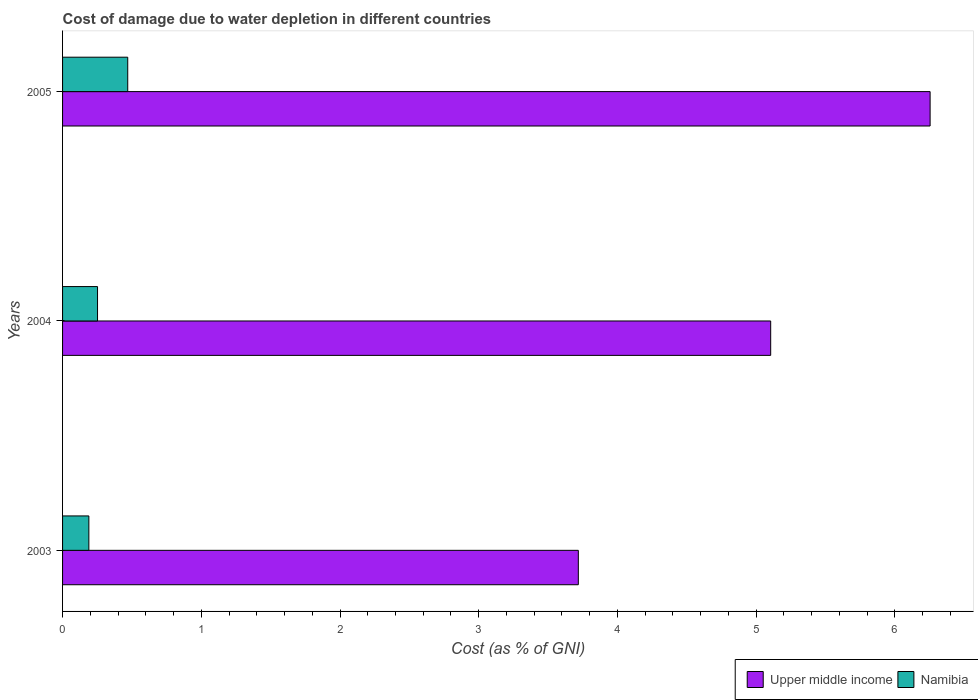How many groups of bars are there?
Offer a terse response. 3. What is the cost of damage caused due to water depletion in Upper middle income in 2003?
Your response must be concise. 3.72. Across all years, what is the maximum cost of damage caused due to water depletion in Upper middle income?
Ensure brevity in your answer.  6.25. Across all years, what is the minimum cost of damage caused due to water depletion in Upper middle income?
Ensure brevity in your answer.  3.72. What is the total cost of damage caused due to water depletion in Upper middle income in the graph?
Your answer should be very brief. 15.08. What is the difference between the cost of damage caused due to water depletion in Namibia in 2003 and that in 2004?
Offer a very short reply. -0.06. What is the difference between the cost of damage caused due to water depletion in Upper middle income in 2004 and the cost of damage caused due to water depletion in Namibia in 2003?
Provide a succinct answer. 4.92. What is the average cost of damage caused due to water depletion in Namibia per year?
Give a very brief answer. 0.3. In the year 2005, what is the difference between the cost of damage caused due to water depletion in Namibia and cost of damage caused due to water depletion in Upper middle income?
Provide a short and direct response. -5.78. In how many years, is the cost of damage caused due to water depletion in Namibia greater than 2.2 %?
Offer a terse response. 0. What is the ratio of the cost of damage caused due to water depletion in Namibia in 2003 to that in 2005?
Provide a short and direct response. 0.4. Is the cost of damage caused due to water depletion in Namibia in 2004 less than that in 2005?
Offer a very short reply. Yes. What is the difference between the highest and the second highest cost of damage caused due to water depletion in Namibia?
Your answer should be very brief. 0.22. What is the difference between the highest and the lowest cost of damage caused due to water depletion in Namibia?
Your answer should be compact. 0.28. In how many years, is the cost of damage caused due to water depletion in Namibia greater than the average cost of damage caused due to water depletion in Namibia taken over all years?
Provide a succinct answer. 1. Is the sum of the cost of damage caused due to water depletion in Upper middle income in 2003 and 2005 greater than the maximum cost of damage caused due to water depletion in Namibia across all years?
Your answer should be very brief. Yes. What does the 1st bar from the top in 2004 represents?
Your answer should be very brief. Namibia. What does the 2nd bar from the bottom in 2004 represents?
Your answer should be very brief. Namibia. Are the values on the major ticks of X-axis written in scientific E-notation?
Your answer should be very brief. No. Does the graph contain grids?
Your response must be concise. No. Where does the legend appear in the graph?
Offer a very short reply. Bottom right. What is the title of the graph?
Your answer should be compact. Cost of damage due to water depletion in different countries. What is the label or title of the X-axis?
Offer a very short reply. Cost (as % of GNI). What is the Cost (as % of GNI) in Upper middle income in 2003?
Offer a terse response. 3.72. What is the Cost (as % of GNI) of Namibia in 2003?
Provide a short and direct response. 0.19. What is the Cost (as % of GNI) in Upper middle income in 2004?
Your answer should be compact. 5.1. What is the Cost (as % of GNI) of Namibia in 2004?
Your answer should be compact. 0.25. What is the Cost (as % of GNI) of Upper middle income in 2005?
Keep it short and to the point. 6.25. What is the Cost (as % of GNI) in Namibia in 2005?
Make the answer very short. 0.47. Across all years, what is the maximum Cost (as % of GNI) in Upper middle income?
Give a very brief answer. 6.25. Across all years, what is the maximum Cost (as % of GNI) in Namibia?
Offer a very short reply. 0.47. Across all years, what is the minimum Cost (as % of GNI) of Upper middle income?
Offer a terse response. 3.72. Across all years, what is the minimum Cost (as % of GNI) in Namibia?
Provide a short and direct response. 0.19. What is the total Cost (as % of GNI) of Upper middle income in the graph?
Your answer should be very brief. 15.08. What is the total Cost (as % of GNI) of Namibia in the graph?
Ensure brevity in your answer.  0.91. What is the difference between the Cost (as % of GNI) in Upper middle income in 2003 and that in 2004?
Give a very brief answer. -1.39. What is the difference between the Cost (as % of GNI) of Namibia in 2003 and that in 2004?
Keep it short and to the point. -0.06. What is the difference between the Cost (as % of GNI) in Upper middle income in 2003 and that in 2005?
Ensure brevity in your answer.  -2.54. What is the difference between the Cost (as % of GNI) of Namibia in 2003 and that in 2005?
Provide a short and direct response. -0.28. What is the difference between the Cost (as % of GNI) of Upper middle income in 2004 and that in 2005?
Keep it short and to the point. -1.15. What is the difference between the Cost (as % of GNI) of Namibia in 2004 and that in 2005?
Provide a short and direct response. -0.22. What is the difference between the Cost (as % of GNI) of Upper middle income in 2003 and the Cost (as % of GNI) of Namibia in 2004?
Your response must be concise. 3.47. What is the difference between the Cost (as % of GNI) in Upper middle income in 2003 and the Cost (as % of GNI) in Namibia in 2005?
Your answer should be very brief. 3.25. What is the difference between the Cost (as % of GNI) of Upper middle income in 2004 and the Cost (as % of GNI) of Namibia in 2005?
Provide a short and direct response. 4.64. What is the average Cost (as % of GNI) of Upper middle income per year?
Give a very brief answer. 5.03. What is the average Cost (as % of GNI) of Namibia per year?
Your answer should be compact. 0.3. In the year 2003, what is the difference between the Cost (as % of GNI) of Upper middle income and Cost (as % of GNI) of Namibia?
Ensure brevity in your answer.  3.53. In the year 2004, what is the difference between the Cost (as % of GNI) of Upper middle income and Cost (as % of GNI) of Namibia?
Give a very brief answer. 4.85. In the year 2005, what is the difference between the Cost (as % of GNI) in Upper middle income and Cost (as % of GNI) in Namibia?
Give a very brief answer. 5.78. What is the ratio of the Cost (as % of GNI) in Upper middle income in 2003 to that in 2004?
Your answer should be compact. 0.73. What is the ratio of the Cost (as % of GNI) of Namibia in 2003 to that in 2004?
Provide a succinct answer. 0.75. What is the ratio of the Cost (as % of GNI) in Upper middle income in 2003 to that in 2005?
Your answer should be very brief. 0.59. What is the ratio of the Cost (as % of GNI) in Namibia in 2003 to that in 2005?
Keep it short and to the point. 0.4. What is the ratio of the Cost (as % of GNI) of Upper middle income in 2004 to that in 2005?
Offer a terse response. 0.82. What is the ratio of the Cost (as % of GNI) in Namibia in 2004 to that in 2005?
Your answer should be very brief. 0.54. What is the difference between the highest and the second highest Cost (as % of GNI) in Upper middle income?
Your response must be concise. 1.15. What is the difference between the highest and the second highest Cost (as % of GNI) in Namibia?
Keep it short and to the point. 0.22. What is the difference between the highest and the lowest Cost (as % of GNI) in Upper middle income?
Ensure brevity in your answer.  2.54. What is the difference between the highest and the lowest Cost (as % of GNI) in Namibia?
Your answer should be compact. 0.28. 